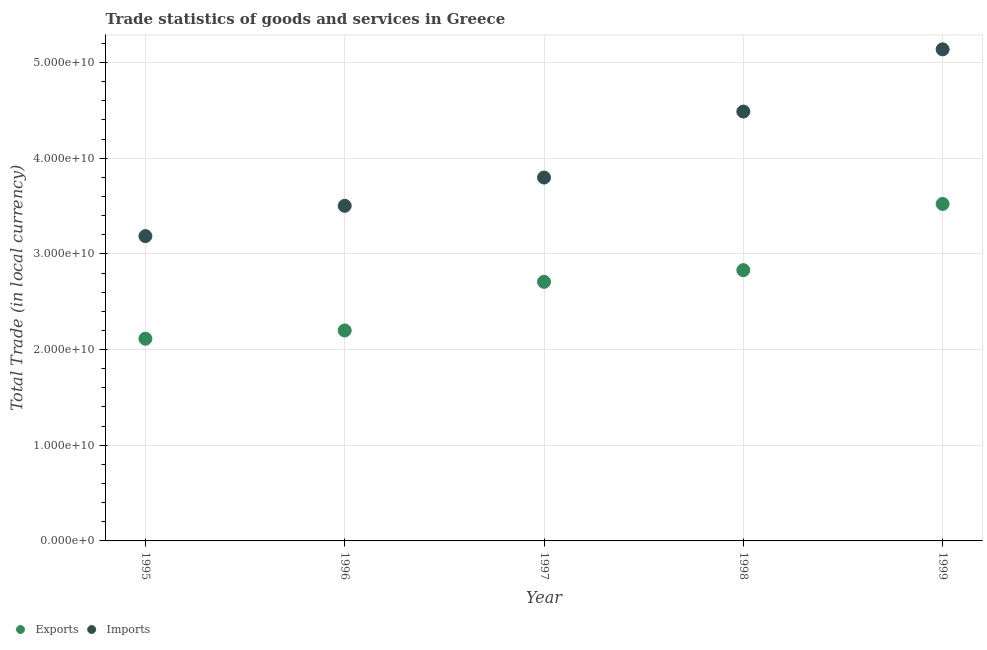What is the export of goods and services in 1998?
Keep it short and to the point. 2.83e+1. Across all years, what is the maximum export of goods and services?
Provide a succinct answer. 3.52e+1. Across all years, what is the minimum imports of goods and services?
Your response must be concise. 3.19e+1. In which year was the imports of goods and services maximum?
Give a very brief answer. 1999. What is the total imports of goods and services in the graph?
Provide a succinct answer. 2.01e+11. What is the difference between the imports of goods and services in 1996 and that in 1998?
Ensure brevity in your answer.  -9.85e+09. What is the difference between the imports of goods and services in 1997 and the export of goods and services in 1999?
Make the answer very short. 2.76e+09. What is the average export of goods and services per year?
Keep it short and to the point. 2.67e+1. In the year 1995, what is the difference between the imports of goods and services and export of goods and services?
Provide a short and direct response. 1.07e+1. In how many years, is the export of goods and services greater than 4000000000 LCU?
Give a very brief answer. 5. What is the ratio of the export of goods and services in 1997 to that in 1999?
Offer a terse response. 0.77. Is the imports of goods and services in 1996 less than that in 1997?
Provide a short and direct response. Yes. Is the difference between the export of goods and services in 1995 and 1998 greater than the difference between the imports of goods and services in 1995 and 1998?
Your response must be concise. Yes. What is the difference between the highest and the second highest export of goods and services?
Keep it short and to the point. 6.92e+09. What is the difference between the highest and the lowest export of goods and services?
Your answer should be very brief. 1.41e+1. In how many years, is the imports of goods and services greater than the average imports of goods and services taken over all years?
Ensure brevity in your answer.  2. Is the sum of the export of goods and services in 1995 and 1996 greater than the maximum imports of goods and services across all years?
Provide a succinct answer. No. Does the export of goods and services monotonically increase over the years?
Provide a short and direct response. Yes. How many years are there in the graph?
Offer a terse response. 5. Does the graph contain any zero values?
Make the answer very short. No. Does the graph contain grids?
Offer a terse response. Yes. Where does the legend appear in the graph?
Your answer should be compact. Bottom left. How many legend labels are there?
Your answer should be very brief. 2. What is the title of the graph?
Offer a very short reply. Trade statistics of goods and services in Greece. Does "Foreign liabilities" appear as one of the legend labels in the graph?
Your answer should be very brief. No. What is the label or title of the Y-axis?
Offer a terse response. Total Trade (in local currency). What is the Total Trade (in local currency) of Exports in 1995?
Your response must be concise. 2.11e+1. What is the Total Trade (in local currency) in Imports in 1995?
Make the answer very short. 3.19e+1. What is the Total Trade (in local currency) in Exports in 1996?
Offer a very short reply. 2.20e+1. What is the Total Trade (in local currency) in Imports in 1996?
Provide a short and direct response. 3.50e+1. What is the Total Trade (in local currency) in Exports in 1997?
Your answer should be very brief. 2.71e+1. What is the Total Trade (in local currency) of Imports in 1997?
Keep it short and to the point. 3.80e+1. What is the Total Trade (in local currency) of Exports in 1998?
Offer a terse response. 2.83e+1. What is the Total Trade (in local currency) of Imports in 1998?
Offer a very short reply. 4.49e+1. What is the Total Trade (in local currency) of Exports in 1999?
Offer a terse response. 3.52e+1. What is the Total Trade (in local currency) of Imports in 1999?
Your answer should be very brief. 5.14e+1. Across all years, what is the maximum Total Trade (in local currency) in Exports?
Your response must be concise. 3.52e+1. Across all years, what is the maximum Total Trade (in local currency) of Imports?
Your response must be concise. 5.14e+1. Across all years, what is the minimum Total Trade (in local currency) in Exports?
Ensure brevity in your answer.  2.11e+1. Across all years, what is the minimum Total Trade (in local currency) in Imports?
Give a very brief answer. 3.19e+1. What is the total Total Trade (in local currency) of Exports in the graph?
Keep it short and to the point. 1.34e+11. What is the total Total Trade (in local currency) in Imports in the graph?
Ensure brevity in your answer.  2.01e+11. What is the difference between the Total Trade (in local currency) of Exports in 1995 and that in 1996?
Provide a short and direct response. -8.63e+08. What is the difference between the Total Trade (in local currency) in Imports in 1995 and that in 1996?
Ensure brevity in your answer.  -3.17e+09. What is the difference between the Total Trade (in local currency) of Exports in 1995 and that in 1997?
Keep it short and to the point. -5.94e+09. What is the difference between the Total Trade (in local currency) of Imports in 1995 and that in 1997?
Provide a short and direct response. -6.12e+09. What is the difference between the Total Trade (in local currency) in Exports in 1995 and that in 1998?
Your answer should be compact. -7.17e+09. What is the difference between the Total Trade (in local currency) of Imports in 1995 and that in 1998?
Your answer should be very brief. -1.30e+1. What is the difference between the Total Trade (in local currency) in Exports in 1995 and that in 1999?
Your answer should be very brief. -1.41e+1. What is the difference between the Total Trade (in local currency) of Imports in 1995 and that in 1999?
Your response must be concise. -1.95e+1. What is the difference between the Total Trade (in local currency) of Exports in 1996 and that in 1997?
Your answer should be very brief. -5.08e+09. What is the difference between the Total Trade (in local currency) of Imports in 1996 and that in 1997?
Keep it short and to the point. -2.96e+09. What is the difference between the Total Trade (in local currency) of Exports in 1996 and that in 1998?
Ensure brevity in your answer.  -6.30e+09. What is the difference between the Total Trade (in local currency) in Imports in 1996 and that in 1998?
Give a very brief answer. -9.85e+09. What is the difference between the Total Trade (in local currency) of Exports in 1996 and that in 1999?
Your response must be concise. -1.32e+1. What is the difference between the Total Trade (in local currency) of Imports in 1996 and that in 1999?
Provide a succinct answer. -1.64e+1. What is the difference between the Total Trade (in local currency) in Exports in 1997 and that in 1998?
Offer a terse response. -1.22e+09. What is the difference between the Total Trade (in local currency) of Imports in 1997 and that in 1998?
Provide a short and direct response. -6.90e+09. What is the difference between the Total Trade (in local currency) in Exports in 1997 and that in 1999?
Provide a succinct answer. -8.14e+09. What is the difference between the Total Trade (in local currency) in Imports in 1997 and that in 1999?
Ensure brevity in your answer.  -1.34e+1. What is the difference between the Total Trade (in local currency) of Exports in 1998 and that in 1999?
Offer a terse response. -6.92e+09. What is the difference between the Total Trade (in local currency) of Imports in 1998 and that in 1999?
Offer a very short reply. -6.50e+09. What is the difference between the Total Trade (in local currency) in Exports in 1995 and the Total Trade (in local currency) in Imports in 1996?
Provide a short and direct response. -1.39e+1. What is the difference between the Total Trade (in local currency) of Exports in 1995 and the Total Trade (in local currency) of Imports in 1997?
Your answer should be compact. -1.68e+1. What is the difference between the Total Trade (in local currency) in Exports in 1995 and the Total Trade (in local currency) in Imports in 1998?
Keep it short and to the point. -2.37e+1. What is the difference between the Total Trade (in local currency) in Exports in 1995 and the Total Trade (in local currency) in Imports in 1999?
Give a very brief answer. -3.02e+1. What is the difference between the Total Trade (in local currency) of Exports in 1996 and the Total Trade (in local currency) of Imports in 1997?
Keep it short and to the point. -1.60e+1. What is the difference between the Total Trade (in local currency) in Exports in 1996 and the Total Trade (in local currency) in Imports in 1998?
Ensure brevity in your answer.  -2.29e+1. What is the difference between the Total Trade (in local currency) in Exports in 1996 and the Total Trade (in local currency) in Imports in 1999?
Make the answer very short. -2.94e+1. What is the difference between the Total Trade (in local currency) of Exports in 1997 and the Total Trade (in local currency) of Imports in 1998?
Ensure brevity in your answer.  -1.78e+1. What is the difference between the Total Trade (in local currency) in Exports in 1997 and the Total Trade (in local currency) in Imports in 1999?
Your response must be concise. -2.43e+1. What is the difference between the Total Trade (in local currency) of Exports in 1998 and the Total Trade (in local currency) of Imports in 1999?
Offer a terse response. -2.31e+1. What is the average Total Trade (in local currency) in Exports per year?
Ensure brevity in your answer.  2.67e+1. What is the average Total Trade (in local currency) in Imports per year?
Your response must be concise. 4.02e+1. In the year 1995, what is the difference between the Total Trade (in local currency) of Exports and Total Trade (in local currency) of Imports?
Ensure brevity in your answer.  -1.07e+1. In the year 1996, what is the difference between the Total Trade (in local currency) of Exports and Total Trade (in local currency) of Imports?
Offer a very short reply. -1.30e+1. In the year 1997, what is the difference between the Total Trade (in local currency) in Exports and Total Trade (in local currency) in Imports?
Your answer should be very brief. -1.09e+1. In the year 1998, what is the difference between the Total Trade (in local currency) in Exports and Total Trade (in local currency) in Imports?
Provide a short and direct response. -1.66e+1. In the year 1999, what is the difference between the Total Trade (in local currency) of Exports and Total Trade (in local currency) of Imports?
Provide a succinct answer. -1.62e+1. What is the ratio of the Total Trade (in local currency) of Exports in 1995 to that in 1996?
Offer a very short reply. 0.96. What is the ratio of the Total Trade (in local currency) of Imports in 1995 to that in 1996?
Give a very brief answer. 0.91. What is the ratio of the Total Trade (in local currency) in Exports in 1995 to that in 1997?
Provide a succinct answer. 0.78. What is the ratio of the Total Trade (in local currency) in Imports in 1995 to that in 1997?
Offer a very short reply. 0.84. What is the ratio of the Total Trade (in local currency) in Exports in 1995 to that in 1998?
Your answer should be very brief. 0.75. What is the ratio of the Total Trade (in local currency) in Imports in 1995 to that in 1998?
Offer a very short reply. 0.71. What is the ratio of the Total Trade (in local currency) of Exports in 1995 to that in 1999?
Offer a terse response. 0.6. What is the ratio of the Total Trade (in local currency) of Imports in 1995 to that in 1999?
Your answer should be compact. 0.62. What is the ratio of the Total Trade (in local currency) in Exports in 1996 to that in 1997?
Your response must be concise. 0.81. What is the ratio of the Total Trade (in local currency) of Imports in 1996 to that in 1997?
Make the answer very short. 0.92. What is the ratio of the Total Trade (in local currency) in Exports in 1996 to that in 1998?
Your response must be concise. 0.78. What is the ratio of the Total Trade (in local currency) in Imports in 1996 to that in 1998?
Give a very brief answer. 0.78. What is the ratio of the Total Trade (in local currency) of Exports in 1996 to that in 1999?
Provide a short and direct response. 0.62. What is the ratio of the Total Trade (in local currency) of Imports in 1996 to that in 1999?
Keep it short and to the point. 0.68. What is the ratio of the Total Trade (in local currency) in Exports in 1997 to that in 1998?
Give a very brief answer. 0.96. What is the ratio of the Total Trade (in local currency) of Imports in 1997 to that in 1998?
Offer a terse response. 0.85. What is the ratio of the Total Trade (in local currency) of Exports in 1997 to that in 1999?
Make the answer very short. 0.77. What is the ratio of the Total Trade (in local currency) in Imports in 1997 to that in 1999?
Provide a succinct answer. 0.74. What is the ratio of the Total Trade (in local currency) of Exports in 1998 to that in 1999?
Make the answer very short. 0.8. What is the ratio of the Total Trade (in local currency) of Imports in 1998 to that in 1999?
Your response must be concise. 0.87. What is the difference between the highest and the second highest Total Trade (in local currency) in Exports?
Give a very brief answer. 6.92e+09. What is the difference between the highest and the second highest Total Trade (in local currency) of Imports?
Provide a succinct answer. 6.50e+09. What is the difference between the highest and the lowest Total Trade (in local currency) of Exports?
Your answer should be very brief. 1.41e+1. What is the difference between the highest and the lowest Total Trade (in local currency) of Imports?
Provide a succinct answer. 1.95e+1. 